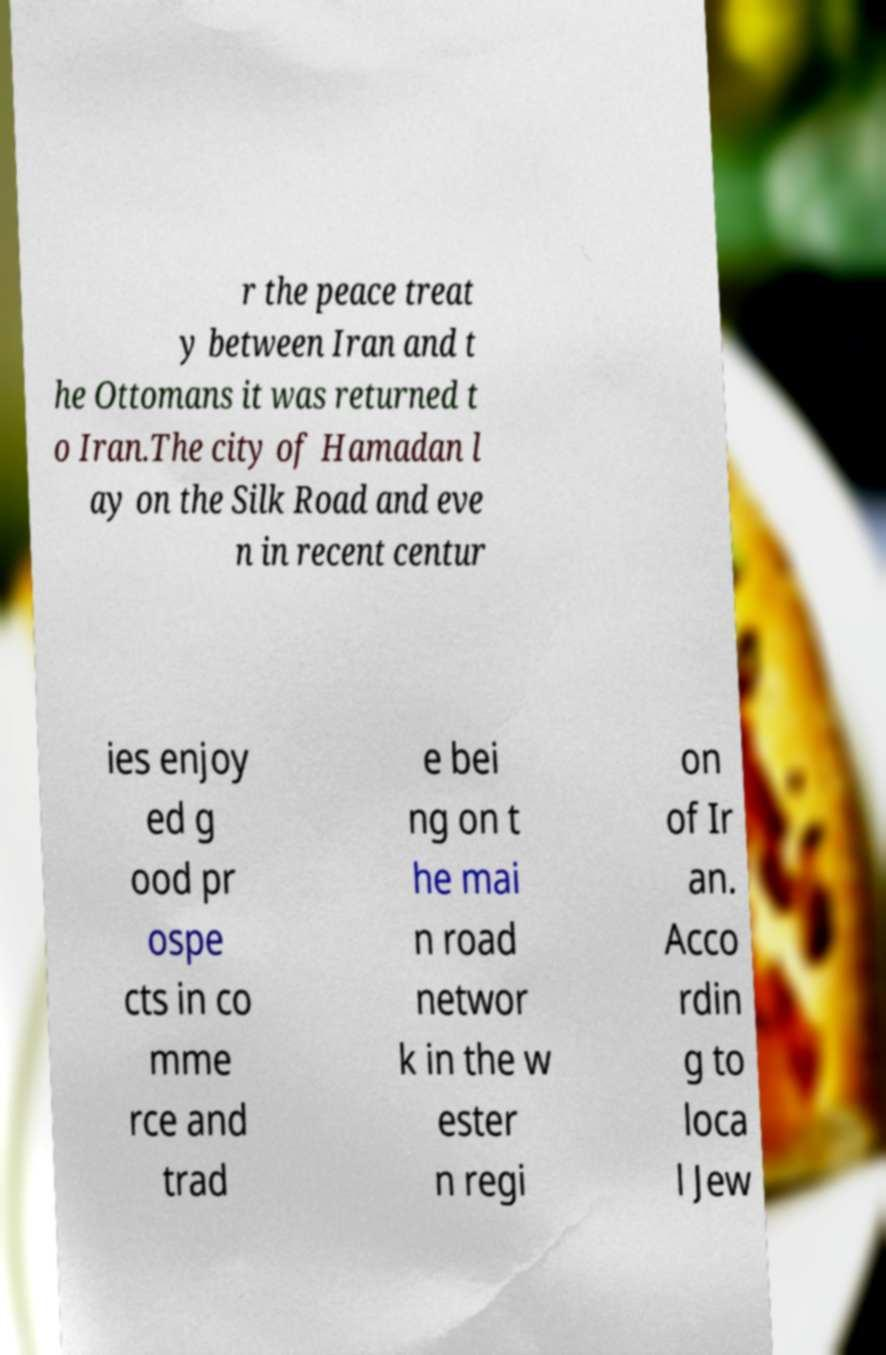Can you accurately transcribe the text from the provided image for me? r the peace treat y between Iran and t he Ottomans it was returned t o Iran.The city of Hamadan l ay on the Silk Road and eve n in recent centur ies enjoy ed g ood pr ospe cts in co mme rce and trad e bei ng on t he mai n road networ k in the w ester n regi on of Ir an. Acco rdin g to loca l Jew 